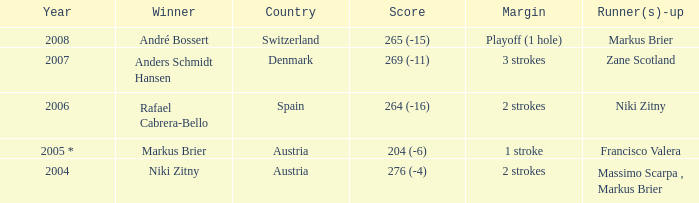Who secured the second position when the gap was 1 stroke? Francisco Valera. 